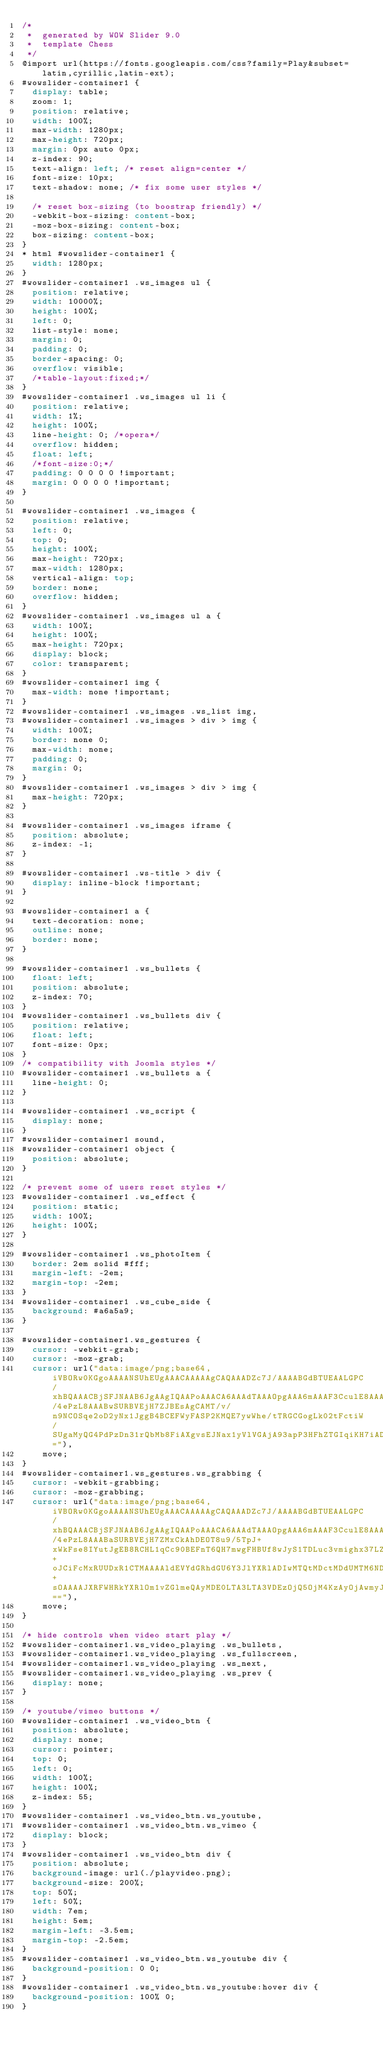<code> <loc_0><loc_0><loc_500><loc_500><_CSS_>/*
 *	generated by WOW Slider 9.0
 *	template Chess
 */
@import url(https://fonts.googleapis.com/css?family=Play&subset=latin,cyrillic,latin-ext);
#wowslider-container1 {
  display: table;
  zoom: 1;
  position: relative;
  width: 100%;
  max-width: 1280px;
  max-height: 720px;
  margin: 0px auto 0px;
  z-index: 90;
  text-align: left; /* reset align=center */
  font-size: 10px;
  text-shadow: none; /* fix some user styles */

  /* reset box-sizing (to boostrap friendly) */
  -webkit-box-sizing: content-box;
  -moz-box-sizing: content-box;
  box-sizing: content-box;
}
* html #wowslider-container1 {
  width: 1280px;
}
#wowslider-container1 .ws_images ul {
  position: relative;
  width: 10000%;
  height: 100%;
  left: 0;
  list-style: none;
  margin: 0;
  padding: 0;
  border-spacing: 0;
  overflow: visible;
  /*table-layout:fixed;*/
}
#wowslider-container1 .ws_images ul li {
  position: relative;
  width: 1%;
  height: 100%;
  line-height: 0; /*opera*/
  overflow: hidden;
  float: left;
  /*font-size:0;*/
  padding: 0 0 0 0 !important;
  margin: 0 0 0 0 !important;
}

#wowslider-container1 .ws_images {
  position: relative;
  left: 0;
  top: 0;
  height: 100%;
  max-height: 720px;
  max-width: 1280px;
  vertical-align: top;
  border: none;
  overflow: hidden;
}
#wowslider-container1 .ws_images ul a {
  width: 100%;
  height: 100%;
  max-height: 720px;
  display: block;
  color: transparent;
}
#wowslider-container1 img {
  max-width: none !important;
}
#wowslider-container1 .ws_images .ws_list img,
#wowslider-container1 .ws_images > div > img {
  width: 100%;
  border: none 0;
  max-width: none;
  padding: 0;
  margin: 0;
}
#wowslider-container1 .ws_images > div > img {
  max-height: 720px;
}

#wowslider-container1 .ws_images iframe {
  position: absolute;
  z-index: -1;
}

#wowslider-container1 .ws-title > div {
  display: inline-block !important;
}

#wowslider-container1 a {
  text-decoration: none;
  outline: none;
  border: none;
}

#wowslider-container1 .ws_bullets {
  float: left;
  position: absolute;
  z-index: 70;
}
#wowslider-container1 .ws_bullets div {
  position: relative;
  float: left;
  font-size: 0px;
}
/* compatibility with Joomla styles */
#wowslider-container1 .ws_bullets a {
  line-height: 0;
}

#wowslider-container1 .ws_script {
  display: none;
}
#wowslider-container1 sound,
#wowslider-container1 object {
  position: absolute;
}

/* prevent some of users reset styles */
#wowslider-container1 .ws_effect {
  position: static;
  width: 100%;
  height: 100%;
}

#wowslider-container1 .ws_photoItem {
  border: 2em solid #fff;
  margin-left: -2em;
  margin-top: -2em;
}
#wowslider-container1 .ws_cube_side {
  background: #a6a5a9;
}

#wowslider-container1.ws_gestures {
  cursor: -webkit-grab;
  cursor: -moz-grab;
  cursor: url("data:image/png;base64,iVBORw0KGgoAAAANSUhEUgAAACAAAAAgCAQAAADZc7J/AAAABGdBTUEAALGPC/xhBQAAACBjSFJNAAB6JgAAgIQAAPoAAACA6AAAdTAAAOpgAAA6mAAAF3CculE8AAAAAmJLR0QA/4ePzL8AAABwSURBVEjH7ZJBEsAgCAMT/v/n9NCOSqe2oD2yNx1JggB4BCEFWyFASP2KMQE7ywWhe/tTRGCGogLk02tFctiW/SUgaMyQG4PdPzDn31rQbMb8FiAXgvsEJNax1yVlVGAjA93apP3HFhZTGIqiKH7iADB6HxPlHdNVAAAAJXRFWHRkYXRlOmNyZWF0ZQAyMDE0LTA3LTA3VDEzOjQ5OjEwKzAyOjAwm7WiFAAAACV0RVh0ZGF0ZTptb2RpZnkAMjAxNC0wNy0wN1QxMzo0OToxMCswMjowMOroGqgAAAAASUVORK5CYII="),
    move;
}
#wowslider-container1.ws_gestures.ws_grabbing {
  cursor: -webkit-grabbing;
  cursor: -moz-grabbing;
  cursor: url("data:image/png;base64,iVBORw0KGgoAAAANSUhEUgAAACAAAAAgCAQAAADZc7J/AAAABGdBTUEAALGPC/xhBQAAACBjSFJNAAB6JgAAgIQAAPoAAACA6AAAdTAAAOpgAAA6mAAAF3CculE8AAAAAmJLR0QA/4ePzL8AAABaSURBVEjH7ZMxCkAhDEOT8u9/5TpJ+xWkFse8IYutJgEB8RCHL1qCc90BEFnT6QH7mwgFHBUf8wJyS1TDLuc3vmighx37LZdIth3E5hKj9n6O0HRh+oJCiFcMxRUUDxR1CTMAAAAldEVYdGRhdGU6Y3JlYXRlADIwMTQtMDctMDdUMTM6NDk6MzgrMDI6MDDqf+sOAAAAJXRFWHRkYXRlOm1vZGlmeQAyMDE0LTA3LTA3VDEzOjQ5OjM4KzAyOjAwmyJTsgAAAABJRU5ErkJggg=="),
    move;
}

/* hide controls when video start play */
#wowslider-container1.ws_video_playing .ws_bullets,
#wowslider-container1.ws_video_playing .ws_fullscreen,
#wowslider-container1.ws_video_playing .ws_next,
#wowslider-container1.ws_video_playing .ws_prev {
  display: none;
}

/* youtube/vimeo buttons */
#wowslider-container1 .ws_video_btn {
  position: absolute;
  display: none;
  cursor: pointer;
  top: 0;
  left: 0;
  width: 100%;
  height: 100%;
  z-index: 55;
}
#wowslider-container1 .ws_video_btn.ws_youtube,
#wowslider-container1 .ws_video_btn.ws_vimeo {
  display: block;
}
#wowslider-container1 .ws_video_btn div {
  position: absolute;
  background-image: url(./playvideo.png);
  background-size: 200%;
  top: 50%;
  left: 50%;
  width: 7em;
  height: 5em;
  margin-left: -3.5em;
  margin-top: -2.5em;
}
#wowslider-container1 .ws_video_btn.ws_youtube div {
  background-position: 0 0;
}
#wowslider-container1 .ws_video_btn.ws_youtube:hover div {
  background-position: 100% 0;
}</code> 